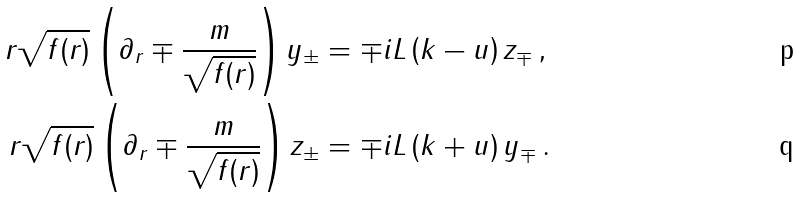Convert formula to latex. <formula><loc_0><loc_0><loc_500><loc_500>r \sqrt { f ( r ) } \left ( \partial _ { r } \mp \frac { m } { \sqrt { f ( r ) } } \right ) y _ { \pm } & = \mp i L \left ( k - u \right ) z _ { \mp } \, , \\ r \sqrt { f ( r ) } \left ( \partial _ { r } \mp \frac { m } { \sqrt { f ( r ) } } \right ) z _ { \pm } & = \mp i L \left ( k + u \right ) y _ { \mp } \, .</formula> 